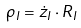Convert formula to latex. <formula><loc_0><loc_0><loc_500><loc_500>\rho _ { I } = { \dot { z } } _ { I } \cdot R _ { I }</formula> 